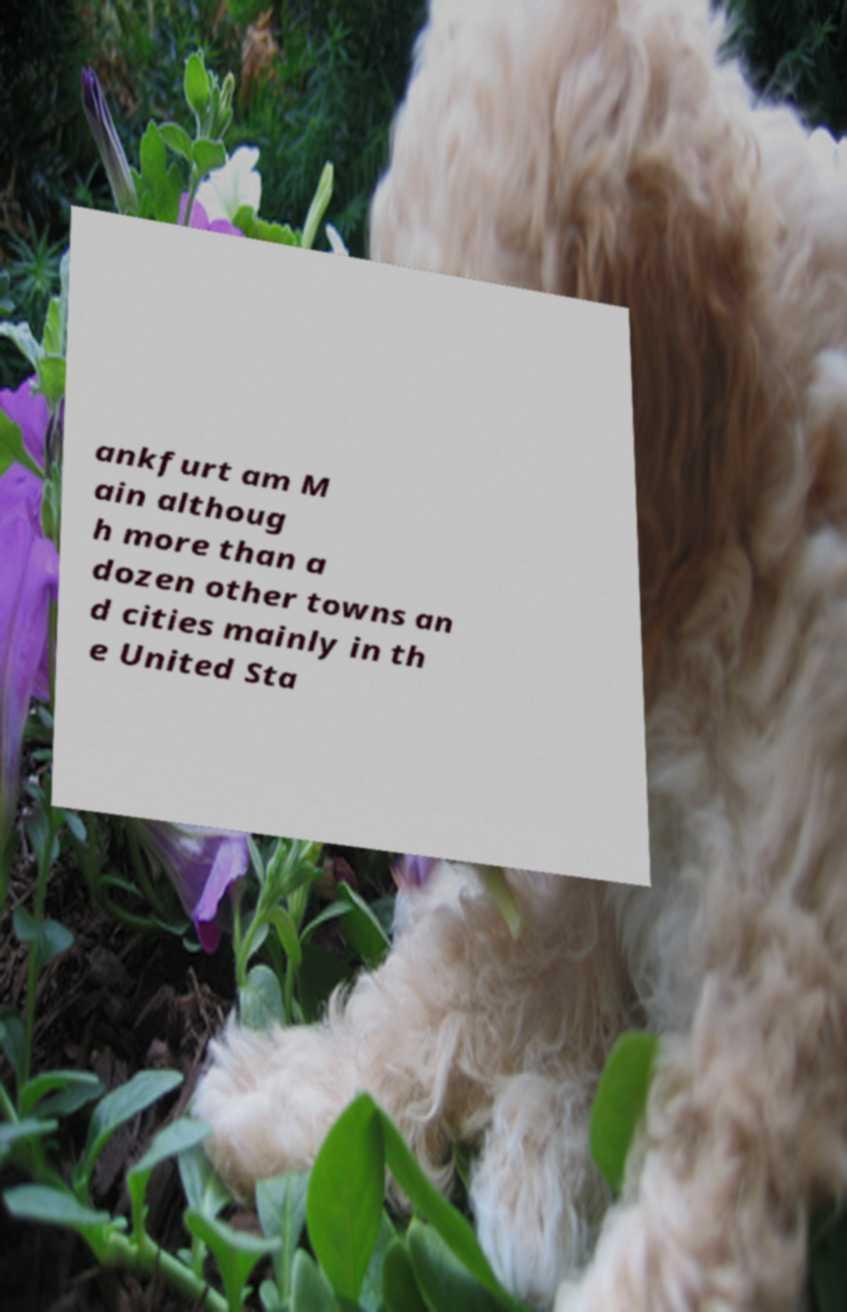Can you read and provide the text displayed in the image?This photo seems to have some interesting text. Can you extract and type it out for me? ankfurt am M ain althoug h more than a dozen other towns an d cities mainly in th e United Sta 